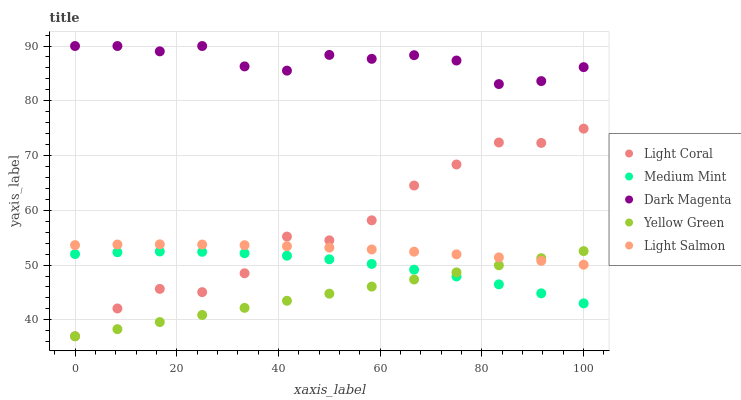Does Yellow Green have the minimum area under the curve?
Answer yes or no. Yes. Does Dark Magenta have the maximum area under the curve?
Answer yes or no. Yes. Does Medium Mint have the minimum area under the curve?
Answer yes or no. No. Does Medium Mint have the maximum area under the curve?
Answer yes or no. No. Is Yellow Green the smoothest?
Answer yes or no. Yes. Is Light Coral the roughest?
Answer yes or no. Yes. Is Medium Mint the smoothest?
Answer yes or no. No. Is Medium Mint the roughest?
Answer yes or no. No. Does Light Coral have the lowest value?
Answer yes or no. Yes. Does Medium Mint have the lowest value?
Answer yes or no. No. Does Dark Magenta have the highest value?
Answer yes or no. Yes. Does Light Salmon have the highest value?
Answer yes or no. No. Is Medium Mint less than Dark Magenta?
Answer yes or no. Yes. Is Dark Magenta greater than Light Salmon?
Answer yes or no. Yes. Does Yellow Green intersect Light Salmon?
Answer yes or no. Yes. Is Yellow Green less than Light Salmon?
Answer yes or no. No. Is Yellow Green greater than Light Salmon?
Answer yes or no. No. Does Medium Mint intersect Dark Magenta?
Answer yes or no. No. 